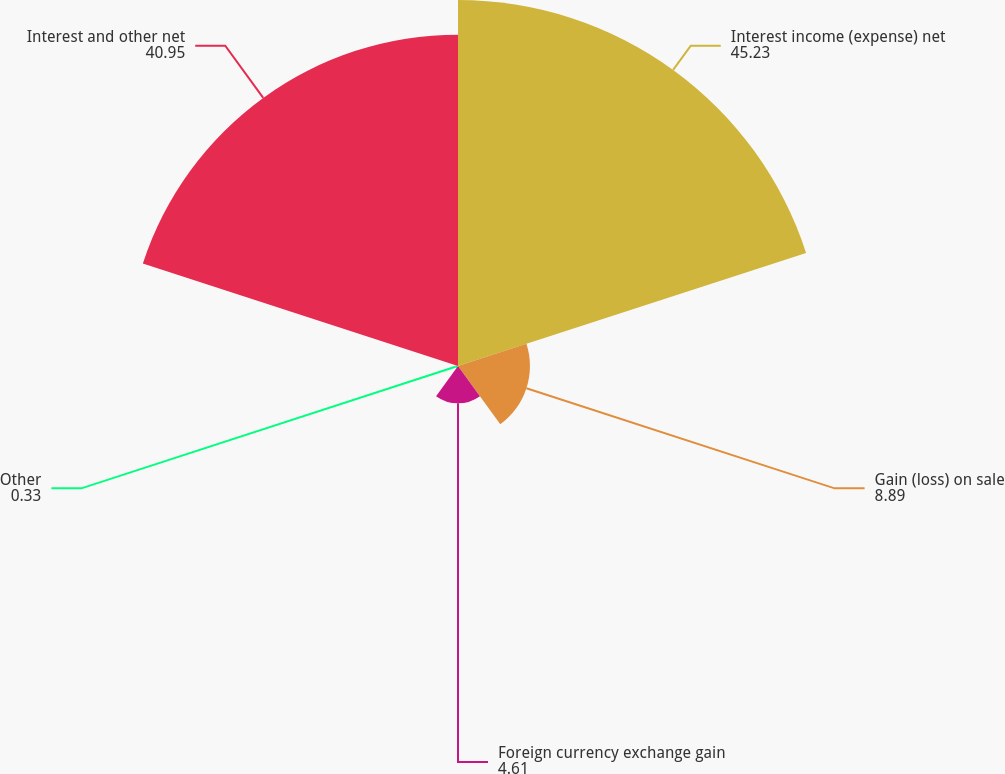Convert chart to OTSL. <chart><loc_0><loc_0><loc_500><loc_500><pie_chart><fcel>Interest income (expense) net<fcel>Gain (loss) on sale<fcel>Foreign currency exchange gain<fcel>Other<fcel>Interest and other net<nl><fcel>45.23%<fcel>8.89%<fcel>4.61%<fcel>0.33%<fcel>40.95%<nl></chart> 